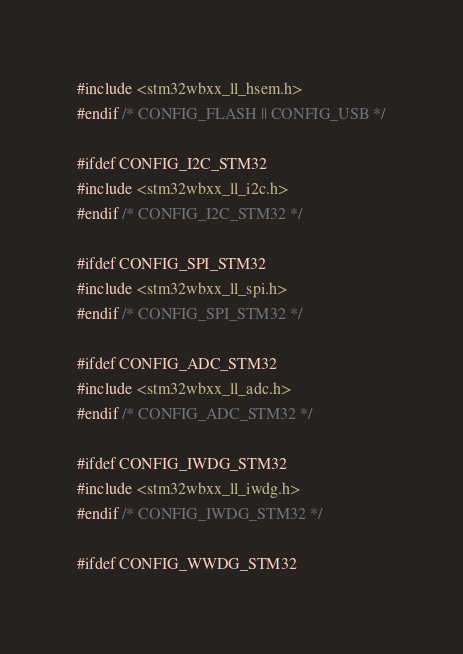Convert code to text. <code><loc_0><loc_0><loc_500><loc_500><_C_>#include <stm32wbxx_ll_hsem.h>
#endif /* CONFIG_FLASH || CONFIG_USB */

#ifdef CONFIG_I2C_STM32
#include <stm32wbxx_ll_i2c.h>
#endif /* CONFIG_I2C_STM32 */

#ifdef CONFIG_SPI_STM32
#include <stm32wbxx_ll_spi.h>
#endif /* CONFIG_SPI_STM32 */

#ifdef CONFIG_ADC_STM32
#include <stm32wbxx_ll_adc.h>
#endif /* CONFIG_ADC_STM32 */

#ifdef CONFIG_IWDG_STM32
#include <stm32wbxx_ll_iwdg.h>
#endif /* CONFIG_IWDG_STM32 */

#ifdef CONFIG_WWDG_STM32</code> 